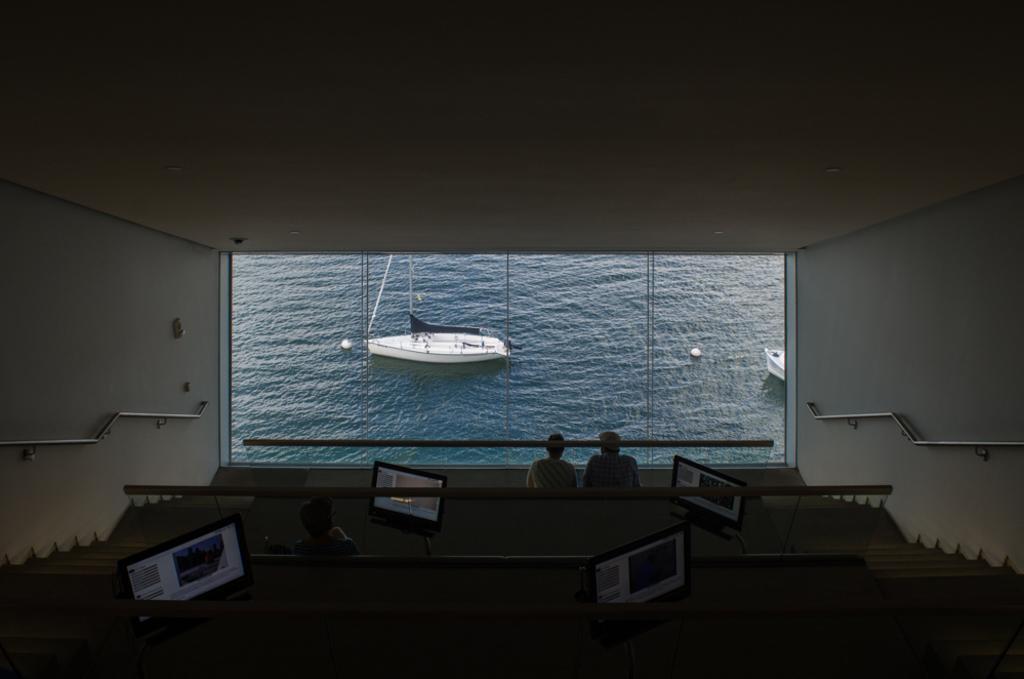Please provide a concise description of this image. Here it is looking like a hall. At the bottom of the image I can see few people are sitting on the benches in front of the laptops. In the background, I can see the water along with two boats. On the right and left side of the image I can see metal rods which are attached to the walls. 